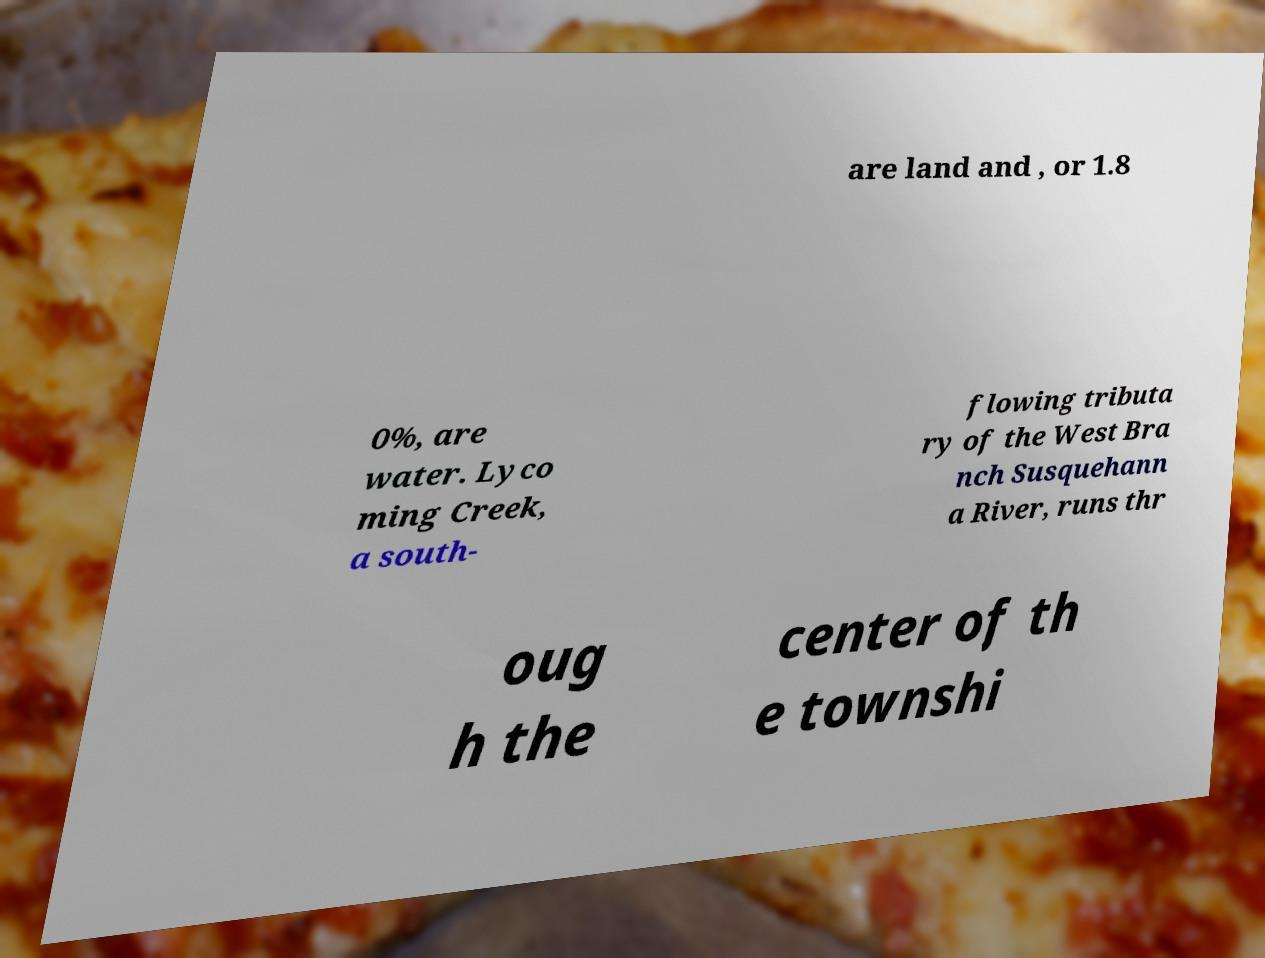There's text embedded in this image that I need extracted. Can you transcribe it verbatim? are land and , or 1.8 0%, are water. Lyco ming Creek, a south- flowing tributa ry of the West Bra nch Susquehann a River, runs thr oug h the center of th e townshi 